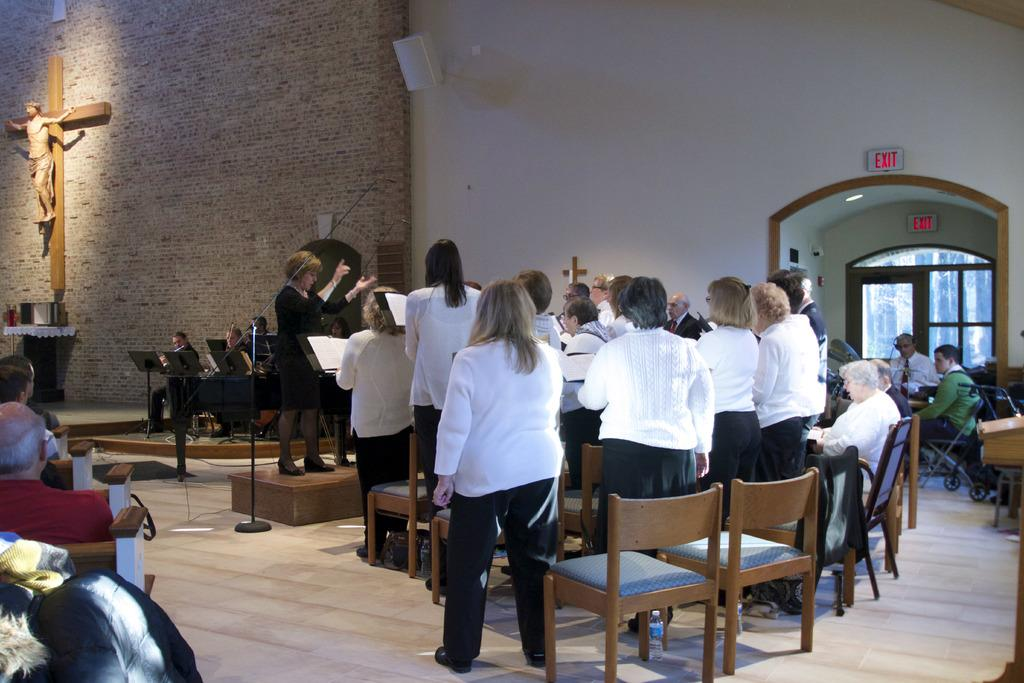What is the main subject of the image? The main subject of the image is a group of people. What are some of the people in the image doing? Some people are standing, and some people are seated on chairs. Can you describe the woman in the image? There is a woman standing in the image. What type of shade is being provided by the woman in the image? There is no shade being provided by the woman in the image, as she is standing and not blocking any sunlight. 